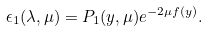Convert formula to latex. <formula><loc_0><loc_0><loc_500><loc_500>\epsilon _ { 1 } ( \lambda , \mu ) = P _ { 1 } ( y , \mu ) e ^ { - 2 \mu f ( y ) } .</formula> 